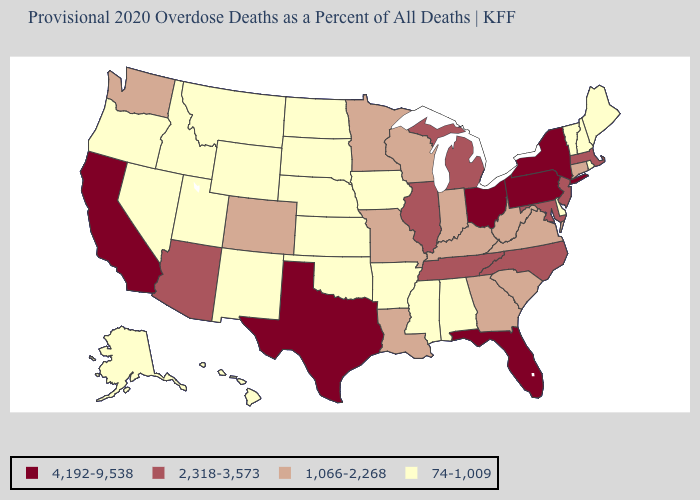What is the lowest value in the South?
Concise answer only. 74-1,009. What is the value of Maine?
Keep it brief. 74-1,009. What is the value of Colorado?
Short answer required. 1,066-2,268. Name the states that have a value in the range 74-1,009?
Answer briefly. Alabama, Alaska, Arkansas, Delaware, Hawaii, Idaho, Iowa, Kansas, Maine, Mississippi, Montana, Nebraska, Nevada, New Hampshire, New Mexico, North Dakota, Oklahoma, Oregon, Rhode Island, South Dakota, Utah, Vermont, Wyoming. Which states have the highest value in the USA?
Keep it brief. California, Florida, New York, Ohio, Pennsylvania, Texas. What is the value of Kentucky?
Give a very brief answer. 1,066-2,268. What is the value of Arizona?
Concise answer only. 2,318-3,573. Does the first symbol in the legend represent the smallest category?
Give a very brief answer. No. Which states have the lowest value in the Northeast?
Quick response, please. Maine, New Hampshire, Rhode Island, Vermont. What is the lowest value in states that border North Dakota?
Short answer required. 74-1,009. Does California have the same value as Florida?
Write a very short answer. Yes. Does Montana have the lowest value in the West?
Concise answer only. Yes. What is the value of Mississippi?
Be succinct. 74-1,009. Does Connecticut have the lowest value in the Northeast?
Be succinct. No. Does Georgia have the highest value in the USA?
Quick response, please. No. 